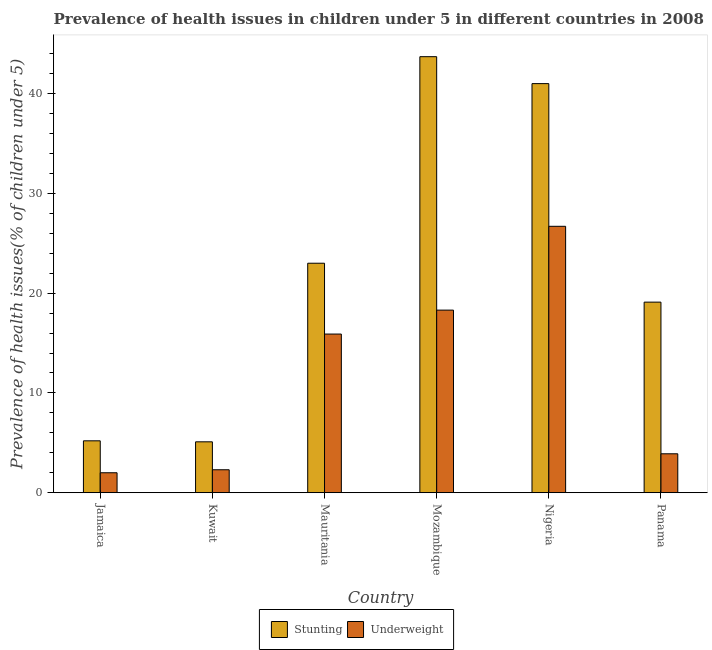Are the number of bars per tick equal to the number of legend labels?
Give a very brief answer. Yes. What is the label of the 2nd group of bars from the left?
Provide a succinct answer. Kuwait. In how many cases, is the number of bars for a given country not equal to the number of legend labels?
Ensure brevity in your answer.  0. What is the percentage of stunted children in Kuwait?
Provide a short and direct response. 5.1. Across all countries, what is the maximum percentage of stunted children?
Your answer should be compact. 43.7. Across all countries, what is the minimum percentage of stunted children?
Offer a terse response. 5.1. In which country was the percentage of stunted children maximum?
Provide a succinct answer. Mozambique. In which country was the percentage of underweight children minimum?
Your answer should be compact. Jamaica. What is the total percentage of stunted children in the graph?
Your answer should be very brief. 137.1. What is the difference between the percentage of underweight children in Mauritania and that in Mozambique?
Provide a succinct answer. -2.4. What is the difference between the percentage of stunted children in Panama and the percentage of underweight children in Jamaica?
Provide a short and direct response. 17.1. What is the average percentage of stunted children per country?
Provide a succinct answer. 22.85. What is the difference between the percentage of underweight children and percentage of stunted children in Panama?
Your response must be concise. -15.2. In how many countries, is the percentage of stunted children greater than 24 %?
Keep it short and to the point. 2. What is the ratio of the percentage of stunted children in Kuwait to that in Mauritania?
Your answer should be very brief. 0.22. Is the percentage of stunted children in Mauritania less than that in Mozambique?
Keep it short and to the point. Yes. Is the difference between the percentage of stunted children in Jamaica and Mauritania greater than the difference between the percentage of underweight children in Jamaica and Mauritania?
Offer a very short reply. No. What is the difference between the highest and the second highest percentage of stunted children?
Your answer should be very brief. 2.7. What is the difference between the highest and the lowest percentage of underweight children?
Provide a succinct answer. 24.7. In how many countries, is the percentage of stunted children greater than the average percentage of stunted children taken over all countries?
Give a very brief answer. 3. Is the sum of the percentage of stunted children in Jamaica and Nigeria greater than the maximum percentage of underweight children across all countries?
Your answer should be very brief. Yes. What does the 1st bar from the left in Kuwait represents?
Ensure brevity in your answer.  Stunting. What does the 1st bar from the right in Mauritania represents?
Give a very brief answer. Underweight. How many bars are there?
Make the answer very short. 12. How many countries are there in the graph?
Keep it short and to the point. 6. What is the difference between two consecutive major ticks on the Y-axis?
Offer a terse response. 10. Does the graph contain any zero values?
Give a very brief answer. No. Does the graph contain grids?
Your answer should be very brief. No. What is the title of the graph?
Keep it short and to the point. Prevalence of health issues in children under 5 in different countries in 2008. What is the label or title of the Y-axis?
Offer a very short reply. Prevalence of health issues(% of children under 5). What is the Prevalence of health issues(% of children under 5) in Stunting in Jamaica?
Your answer should be compact. 5.2. What is the Prevalence of health issues(% of children under 5) in Underweight in Jamaica?
Your answer should be compact. 2. What is the Prevalence of health issues(% of children under 5) in Stunting in Kuwait?
Offer a very short reply. 5.1. What is the Prevalence of health issues(% of children under 5) in Underweight in Kuwait?
Ensure brevity in your answer.  2.3. What is the Prevalence of health issues(% of children under 5) in Stunting in Mauritania?
Provide a succinct answer. 23. What is the Prevalence of health issues(% of children under 5) in Underweight in Mauritania?
Make the answer very short. 15.9. What is the Prevalence of health issues(% of children under 5) in Stunting in Mozambique?
Provide a succinct answer. 43.7. What is the Prevalence of health issues(% of children under 5) in Underweight in Mozambique?
Ensure brevity in your answer.  18.3. What is the Prevalence of health issues(% of children under 5) in Underweight in Nigeria?
Your response must be concise. 26.7. What is the Prevalence of health issues(% of children under 5) in Stunting in Panama?
Offer a very short reply. 19.1. What is the Prevalence of health issues(% of children under 5) in Underweight in Panama?
Keep it short and to the point. 3.9. Across all countries, what is the maximum Prevalence of health issues(% of children under 5) of Stunting?
Make the answer very short. 43.7. Across all countries, what is the maximum Prevalence of health issues(% of children under 5) in Underweight?
Your response must be concise. 26.7. Across all countries, what is the minimum Prevalence of health issues(% of children under 5) of Stunting?
Offer a terse response. 5.1. What is the total Prevalence of health issues(% of children under 5) in Stunting in the graph?
Offer a very short reply. 137.1. What is the total Prevalence of health issues(% of children under 5) of Underweight in the graph?
Ensure brevity in your answer.  69.1. What is the difference between the Prevalence of health issues(% of children under 5) of Underweight in Jamaica and that in Kuwait?
Your answer should be compact. -0.3. What is the difference between the Prevalence of health issues(% of children under 5) in Stunting in Jamaica and that in Mauritania?
Keep it short and to the point. -17.8. What is the difference between the Prevalence of health issues(% of children under 5) in Stunting in Jamaica and that in Mozambique?
Keep it short and to the point. -38.5. What is the difference between the Prevalence of health issues(% of children under 5) in Underweight in Jamaica and that in Mozambique?
Offer a terse response. -16.3. What is the difference between the Prevalence of health issues(% of children under 5) of Stunting in Jamaica and that in Nigeria?
Provide a succinct answer. -35.8. What is the difference between the Prevalence of health issues(% of children under 5) in Underweight in Jamaica and that in Nigeria?
Make the answer very short. -24.7. What is the difference between the Prevalence of health issues(% of children under 5) in Stunting in Jamaica and that in Panama?
Your response must be concise. -13.9. What is the difference between the Prevalence of health issues(% of children under 5) in Underweight in Jamaica and that in Panama?
Ensure brevity in your answer.  -1.9. What is the difference between the Prevalence of health issues(% of children under 5) of Stunting in Kuwait and that in Mauritania?
Your answer should be very brief. -17.9. What is the difference between the Prevalence of health issues(% of children under 5) in Stunting in Kuwait and that in Mozambique?
Your response must be concise. -38.6. What is the difference between the Prevalence of health issues(% of children under 5) in Underweight in Kuwait and that in Mozambique?
Provide a succinct answer. -16. What is the difference between the Prevalence of health issues(% of children under 5) in Stunting in Kuwait and that in Nigeria?
Your answer should be very brief. -35.9. What is the difference between the Prevalence of health issues(% of children under 5) in Underweight in Kuwait and that in Nigeria?
Provide a succinct answer. -24.4. What is the difference between the Prevalence of health issues(% of children under 5) in Stunting in Mauritania and that in Mozambique?
Keep it short and to the point. -20.7. What is the difference between the Prevalence of health issues(% of children under 5) of Stunting in Mauritania and that in Nigeria?
Your answer should be compact. -18. What is the difference between the Prevalence of health issues(% of children under 5) of Underweight in Mozambique and that in Nigeria?
Your response must be concise. -8.4. What is the difference between the Prevalence of health issues(% of children under 5) of Stunting in Mozambique and that in Panama?
Keep it short and to the point. 24.6. What is the difference between the Prevalence of health issues(% of children under 5) in Stunting in Nigeria and that in Panama?
Make the answer very short. 21.9. What is the difference between the Prevalence of health issues(% of children under 5) of Underweight in Nigeria and that in Panama?
Your answer should be very brief. 22.8. What is the difference between the Prevalence of health issues(% of children under 5) of Stunting in Jamaica and the Prevalence of health issues(% of children under 5) of Underweight in Nigeria?
Ensure brevity in your answer.  -21.5. What is the difference between the Prevalence of health issues(% of children under 5) of Stunting in Jamaica and the Prevalence of health issues(% of children under 5) of Underweight in Panama?
Ensure brevity in your answer.  1.3. What is the difference between the Prevalence of health issues(% of children under 5) of Stunting in Kuwait and the Prevalence of health issues(% of children under 5) of Underweight in Mozambique?
Provide a succinct answer. -13.2. What is the difference between the Prevalence of health issues(% of children under 5) of Stunting in Kuwait and the Prevalence of health issues(% of children under 5) of Underweight in Nigeria?
Give a very brief answer. -21.6. What is the difference between the Prevalence of health issues(% of children under 5) of Stunting in Mauritania and the Prevalence of health issues(% of children under 5) of Underweight in Nigeria?
Keep it short and to the point. -3.7. What is the difference between the Prevalence of health issues(% of children under 5) of Stunting in Mozambique and the Prevalence of health issues(% of children under 5) of Underweight in Panama?
Your answer should be very brief. 39.8. What is the difference between the Prevalence of health issues(% of children under 5) of Stunting in Nigeria and the Prevalence of health issues(% of children under 5) of Underweight in Panama?
Give a very brief answer. 37.1. What is the average Prevalence of health issues(% of children under 5) of Stunting per country?
Ensure brevity in your answer.  22.85. What is the average Prevalence of health issues(% of children under 5) in Underweight per country?
Give a very brief answer. 11.52. What is the difference between the Prevalence of health issues(% of children under 5) of Stunting and Prevalence of health issues(% of children under 5) of Underweight in Jamaica?
Keep it short and to the point. 3.2. What is the difference between the Prevalence of health issues(% of children under 5) in Stunting and Prevalence of health issues(% of children under 5) in Underweight in Kuwait?
Your answer should be very brief. 2.8. What is the difference between the Prevalence of health issues(% of children under 5) of Stunting and Prevalence of health issues(% of children under 5) of Underweight in Mozambique?
Make the answer very short. 25.4. What is the difference between the Prevalence of health issues(% of children under 5) in Stunting and Prevalence of health issues(% of children under 5) in Underweight in Nigeria?
Keep it short and to the point. 14.3. What is the ratio of the Prevalence of health issues(% of children under 5) of Stunting in Jamaica to that in Kuwait?
Keep it short and to the point. 1.02. What is the ratio of the Prevalence of health issues(% of children under 5) of Underweight in Jamaica to that in Kuwait?
Your answer should be very brief. 0.87. What is the ratio of the Prevalence of health issues(% of children under 5) of Stunting in Jamaica to that in Mauritania?
Your answer should be very brief. 0.23. What is the ratio of the Prevalence of health issues(% of children under 5) of Underweight in Jamaica to that in Mauritania?
Offer a terse response. 0.13. What is the ratio of the Prevalence of health issues(% of children under 5) in Stunting in Jamaica to that in Mozambique?
Ensure brevity in your answer.  0.12. What is the ratio of the Prevalence of health issues(% of children under 5) in Underweight in Jamaica to that in Mozambique?
Ensure brevity in your answer.  0.11. What is the ratio of the Prevalence of health issues(% of children under 5) of Stunting in Jamaica to that in Nigeria?
Make the answer very short. 0.13. What is the ratio of the Prevalence of health issues(% of children under 5) of Underweight in Jamaica to that in Nigeria?
Your response must be concise. 0.07. What is the ratio of the Prevalence of health issues(% of children under 5) in Stunting in Jamaica to that in Panama?
Provide a succinct answer. 0.27. What is the ratio of the Prevalence of health issues(% of children under 5) in Underweight in Jamaica to that in Panama?
Provide a succinct answer. 0.51. What is the ratio of the Prevalence of health issues(% of children under 5) of Stunting in Kuwait to that in Mauritania?
Offer a very short reply. 0.22. What is the ratio of the Prevalence of health issues(% of children under 5) of Underweight in Kuwait to that in Mauritania?
Ensure brevity in your answer.  0.14. What is the ratio of the Prevalence of health issues(% of children under 5) of Stunting in Kuwait to that in Mozambique?
Your answer should be very brief. 0.12. What is the ratio of the Prevalence of health issues(% of children under 5) in Underweight in Kuwait to that in Mozambique?
Make the answer very short. 0.13. What is the ratio of the Prevalence of health issues(% of children under 5) of Stunting in Kuwait to that in Nigeria?
Your answer should be compact. 0.12. What is the ratio of the Prevalence of health issues(% of children under 5) in Underweight in Kuwait to that in Nigeria?
Your response must be concise. 0.09. What is the ratio of the Prevalence of health issues(% of children under 5) in Stunting in Kuwait to that in Panama?
Provide a short and direct response. 0.27. What is the ratio of the Prevalence of health issues(% of children under 5) in Underweight in Kuwait to that in Panama?
Your response must be concise. 0.59. What is the ratio of the Prevalence of health issues(% of children under 5) in Stunting in Mauritania to that in Mozambique?
Offer a terse response. 0.53. What is the ratio of the Prevalence of health issues(% of children under 5) in Underweight in Mauritania to that in Mozambique?
Your response must be concise. 0.87. What is the ratio of the Prevalence of health issues(% of children under 5) in Stunting in Mauritania to that in Nigeria?
Your answer should be compact. 0.56. What is the ratio of the Prevalence of health issues(% of children under 5) of Underweight in Mauritania to that in Nigeria?
Ensure brevity in your answer.  0.6. What is the ratio of the Prevalence of health issues(% of children under 5) in Stunting in Mauritania to that in Panama?
Your answer should be very brief. 1.2. What is the ratio of the Prevalence of health issues(% of children under 5) of Underweight in Mauritania to that in Panama?
Offer a very short reply. 4.08. What is the ratio of the Prevalence of health issues(% of children under 5) in Stunting in Mozambique to that in Nigeria?
Make the answer very short. 1.07. What is the ratio of the Prevalence of health issues(% of children under 5) in Underweight in Mozambique to that in Nigeria?
Provide a succinct answer. 0.69. What is the ratio of the Prevalence of health issues(% of children under 5) in Stunting in Mozambique to that in Panama?
Your answer should be compact. 2.29. What is the ratio of the Prevalence of health issues(% of children under 5) in Underweight in Mozambique to that in Panama?
Offer a very short reply. 4.69. What is the ratio of the Prevalence of health issues(% of children under 5) of Stunting in Nigeria to that in Panama?
Ensure brevity in your answer.  2.15. What is the ratio of the Prevalence of health issues(% of children under 5) in Underweight in Nigeria to that in Panama?
Provide a short and direct response. 6.85. What is the difference between the highest and the second highest Prevalence of health issues(% of children under 5) in Stunting?
Provide a succinct answer. 2.7. What is the difference between the highest and the second highest Prevalence of health issues(% of children under 5) in Underweight?
Keep it short and to the point. 8.4. What is the difference between the highest and the lowest Prevalence of health issues(% of children under 5) of Stunting?
Offer a very short reply. 38.6. What is the difference between the highest and the lowest Prevalence of health issues(% of children under 5) in Underweight?
Your answer should be compact. 24.7. 